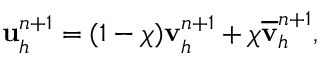Convert formula to latex. <formula><loc_0><loc_0><loc_500><loc_500>\begin{array} { r } { \mathbf u _ { h } ^ { n + 1 } = ( 1 - \chi ) { \mathbf v } _ { h } ^ { n + 1 } + \chi \overline { \mathbf v } _ { h } ^ { n + 1 } , } \end{array}</formula> 